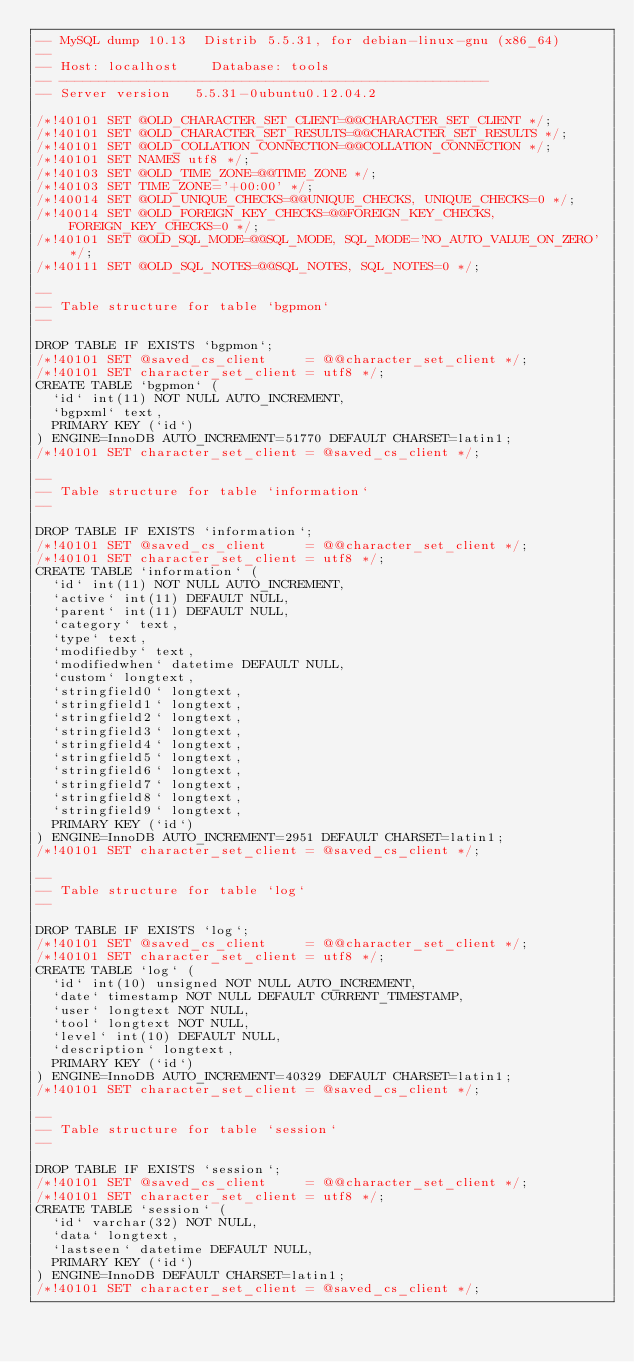<code> <loc_0><loc_0><loc_500><loc_500><_SQL_>-- MySQL dump 10.13  Distrib 5.5.31, for debian-linux-gnu (x86_64)
--
-- Host: localhost    Database: tools
-- ------------------------------------------------------
-- Server version	5.5.31-0ubuntu0.12.04.2

/*!40101 SET @OLD_CHARACTER_SET_CLIENT=@@CHARACTER_SET_CLIENT */;
/*!40101 SET @OLD_CHARACTER_SET_RESULTS=@@CHARACTER_SET_RESULTS */;
/*!40101 SET @OLD_COLLATION_CONNECTION=@@COLLATION_CONNECTION */;
/*!40101 SET NAMES utf8 */;
/*!40103 SET @OLD_TIME_ZONE=@@TIME_ZONE */;
/*!40103 SET TIME_ZONE='+00:00' */;
/*!40014 SET @OLD_UNIQUE_CHECKS=@@UNIQUE_CHECKS, UNIQUE_CHECKS=0 */;
/*!40014 SET @OLD_FOREIGN_KEY_CHECKS=@@FOREIGN_KEY_CHECKS, FOREIGN_KEY_CHECKS=0 */;
/*!40101 SET @OLD_SQL_MODE=@@SQL_MODE, SQL_MODE='NO_AUTO_VALUE_ON_ZERO' */;
/*!40111 SET @OLD_SQL_NOTES=@@SQL_NOTES, SQL_NOTES=0 */;

--
-- Table structure for table `bgpmon`
--

DROP TABLE IF EXISTS `bgpmon`;
/*!40101 SET @saved_cs_client     = @@character_set_client */;
/*!40101 SET character_set_client = utf8 */;
CREATE TABLE `bgpmon` (
  `id` int(11) NOT NULL AUTO_INCREMENT,
  `bgpxml` text,
  PRIMARY KEY (`id`)
) ENGINE=InnoDB AUTO_INCREMENT=51770 DEFAULT CHARSET=latin1;
/*!40101 SET character_set_client = @saved_cs_client */;

--
-- Table structure for table `information`
--

DROP TABLE IF EXISTS `information`;
/*!40101 SET @saved_cs_client     = @@character_set_client */;
/*!40101 SET character_set_client = utf8 */;
CREATE TABLE `information` (
  `id` int(11) NOT NULL AUTO_INCREMENT,
  `active` int(11) DEFAULT NULL,
  `parent` int(11) DEFAULT NULL,
  `category` text,
  `type` text,
  `modifiedby` text,
  `modifiedwhen` datetime DEFAULT NULL,
  `custom` longtext,
  `stringfield0` longtext,
  `stringfield1` longtext,
  `stringfield2` longtext,
  `stringfield3` longtext,
  `stringfield4` longtext,
  `stringfield5` longtext,
  `stringfield6` longtext,
  `stringfield7` longtext,
  `stringfield8` longtext,
  `stringfield9` longtext,
  PRIMARY KEY (`id`)
) ENGINE=InnoDB AUTO_INCREMENT=2951 DEFAULT CHARSET=latin1;
/*!40101 SET character_set_client = @saved_cs_client */;

--
-- Table structure for table `log`
--

DROP TABLE IF EXISTS `log`;
/*!40101 SET @saved_cs_client     = @@character_set_client */;
/*!40101 SET character_set_client = utf8 */;
CREATE TABLE `log` (
  `id` int(10) unsigned NOT NULL AUTO_INCREMENT,
  `date` timestamp NOT NULL DEFAULT CURRENT_TIMESTAMP,
  `user` longtext NOT NULL,
  `tool` longtext NOT NULL,
  `level` int(10) DEFAULT NULL,
  `description` longtext,
  PRIMARY KEY (`id`)
) ENGINE=InnoDB AUTO_INCREMENT=40329 DEFAULT CHARSET=latin1;
/*!40101 SET character_set_client = @saved_cs_client */;

--
-- Table structure for table `session`
--

DROP TABLE IF EXISTS `session`;
/*!40101 SET @saved_cs_client     = @@character_set_client */;
/*!40101 SET character_set_client = utf8 */;
CREATE TABLE `session` (
  `id` varchar(32) NOT NULL,
  `data` longtext,
  `lastseen` datetime DEFAULT NULL,
  PRIMARY KEY (`id`)
) ENGINE=InnoDB DEFAULT CHARSET=latin1;
/*!40101 SET character_set_client = @saved_cs_client */;
</code> 